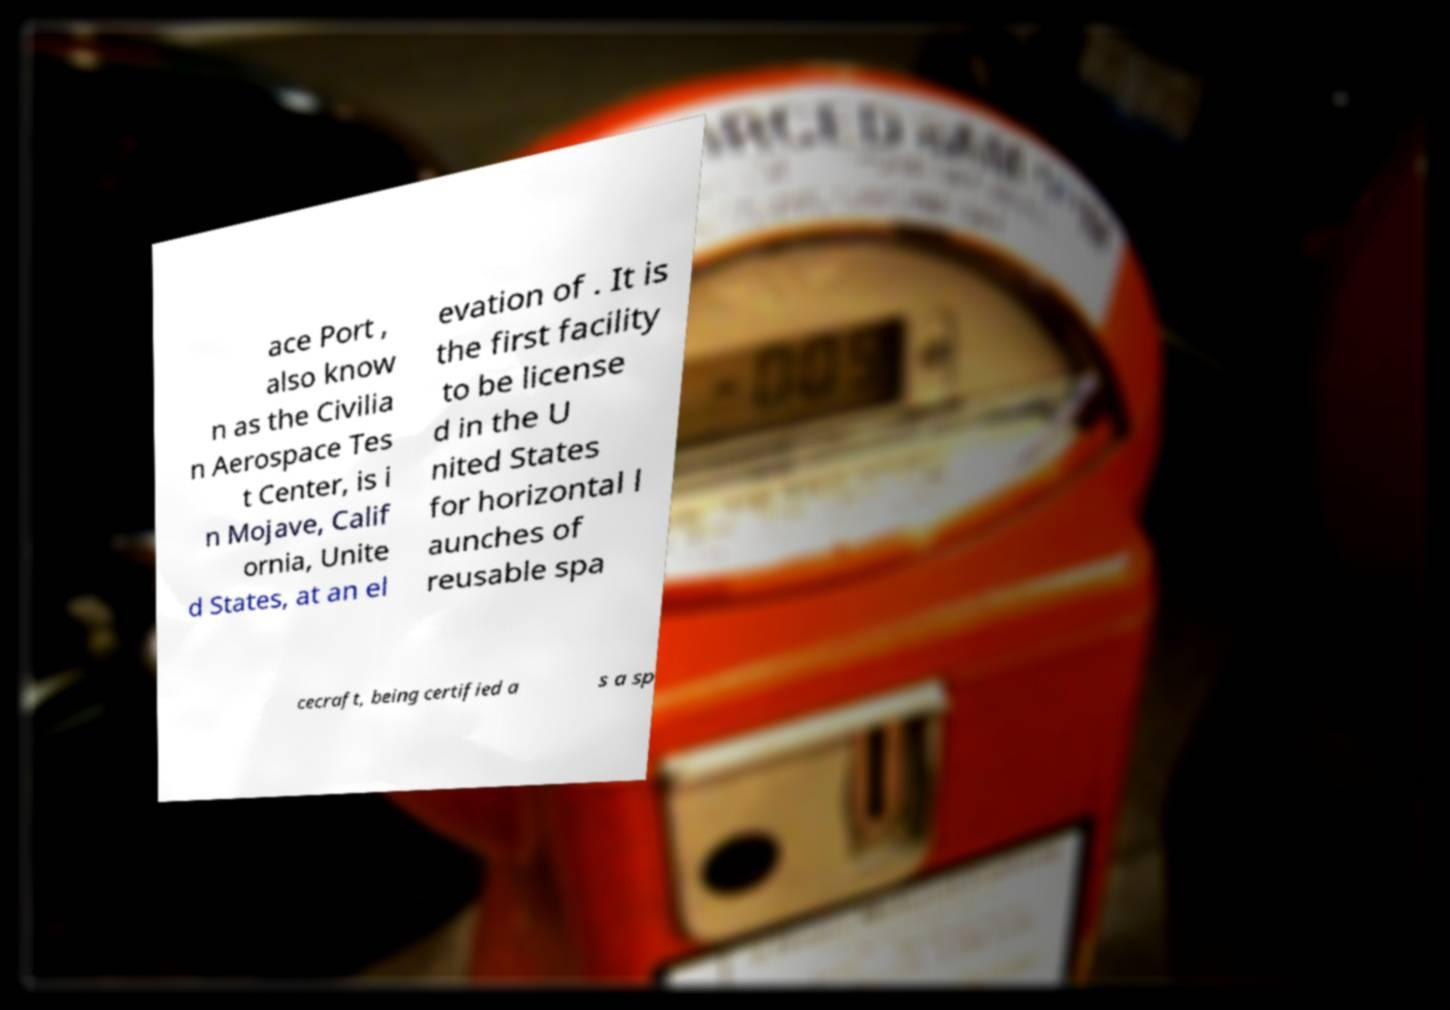I need the written content from this picture converted into text. Can you do that? ace Port , also know n as the Civilia n Aerospace Tes t Center, is i n Mojave, Calif ornia, Unite d States, at an el evation of . It is the first facility to be license d in the U nited States for horizontal l aunches of reusable spa cecraft, being certified a s a sp 